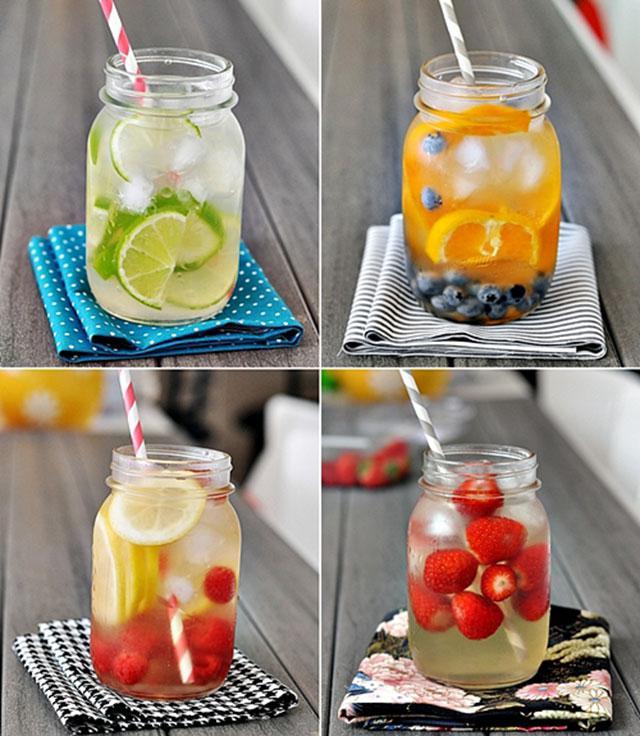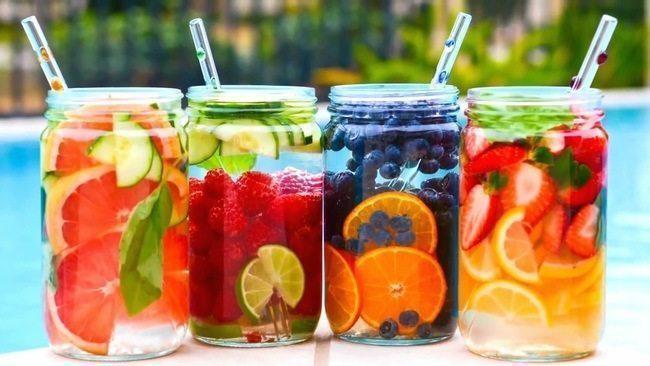The first image is the image on the left, the second image is the image on the right. For the images displayed, is the sentence "The right image shows four fruit-filled cylindrical jars arranged horizontally." factually correct? Answer yes or no. Yes. 